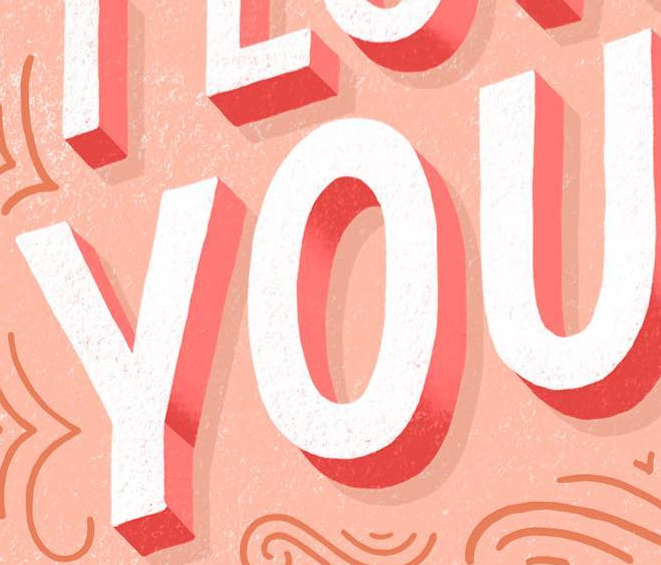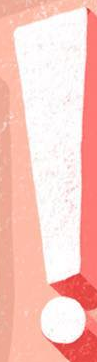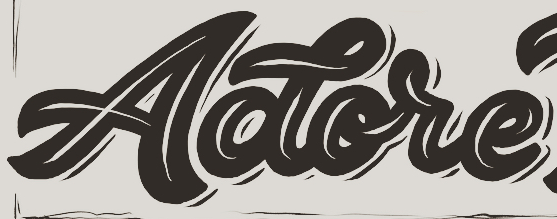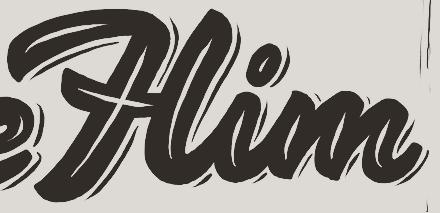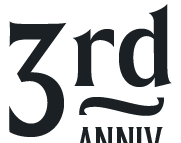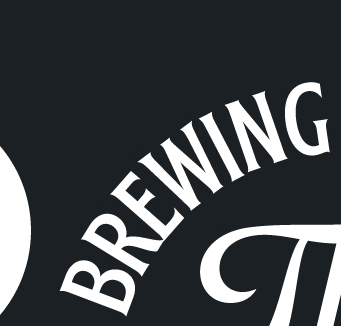Identify the words shown in these images in order, separated by a semicolon. YOU; !; Aotore; Him; 3rd; BREWING 